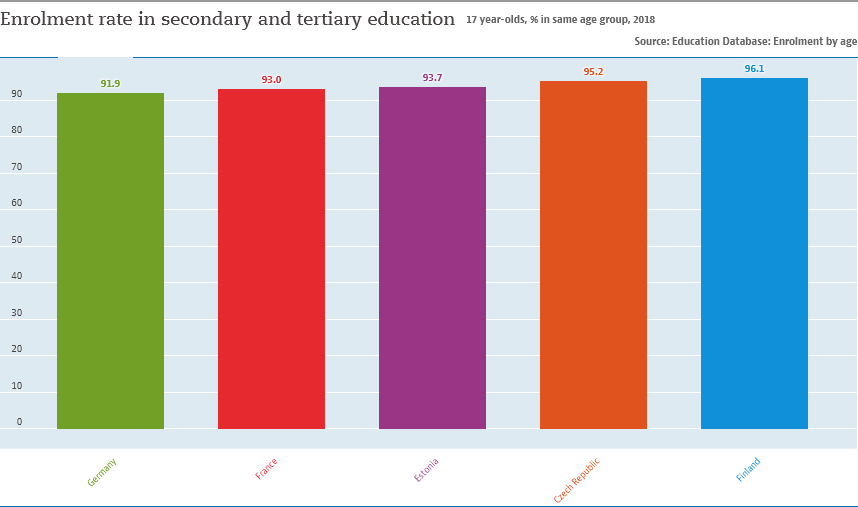Indicate a few pertinent items in this graphic. The median value of all bars is less than the average value of the leftmost and rightmost bars. The enrollment rate in secondary and tertiary education in France is 93%. 